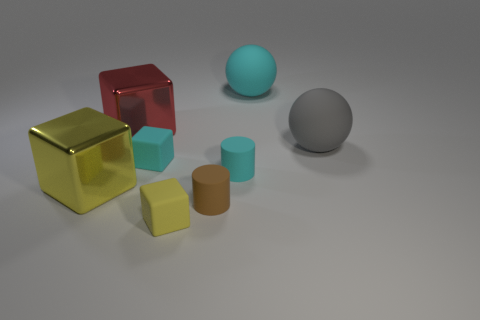Can you describe the arrangement of all the objects in the scene? Certainly! In the scene, there's a collection of objects with various geometric shapes and colors. On the left, a large red sphere with a reflective surface stands out, accompanied by a smaller blue sphere. In the center, there's a prominent large gray sphere with a matte finish. To the right, there are three cubes: a large gold one, a smaller teal one, and the smallest in pale yellow, along with a small cylinder in a muted orange tone. The arrangement has an aesthetic, balanced look with the objects placed on a flat, light surface. 